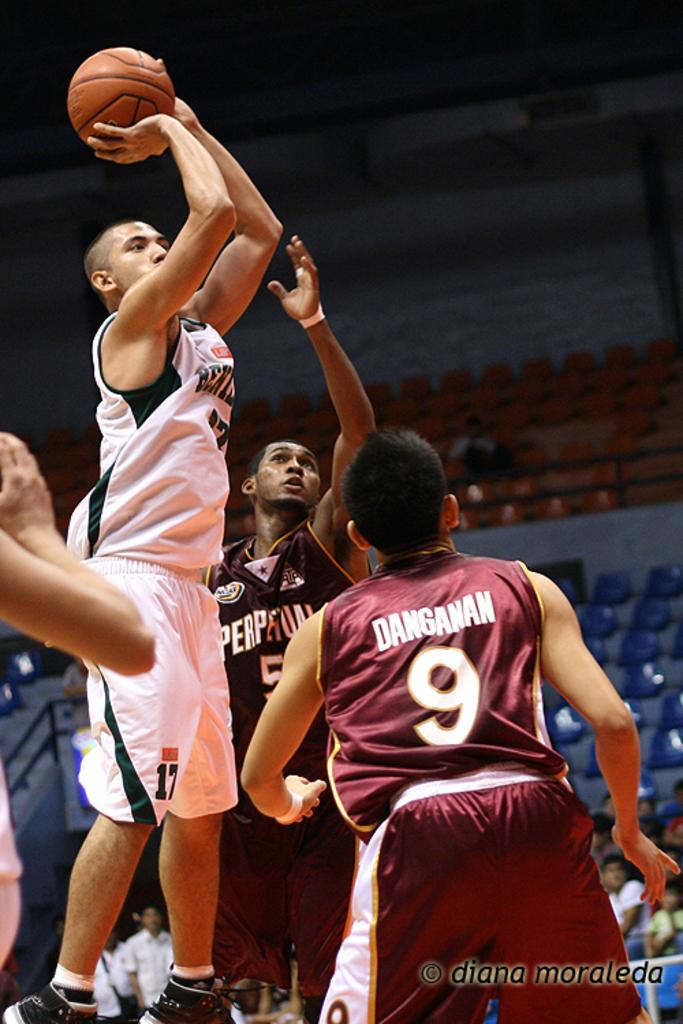<image>
Describe the image concisely. Several basketball players, including one named Danganan, are playing in a game. 